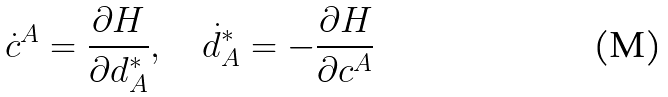<formula> <loc_0><loc_0><loc_500><loc_500>\dot { c } ^ { A } = \frac { \partial H } { \partial d ^ { * } _ { A } } , \quad \dot { d } ^ { * } _ { A } = - \frac { \partial H } { \partial c ^ { A } }</formula> 